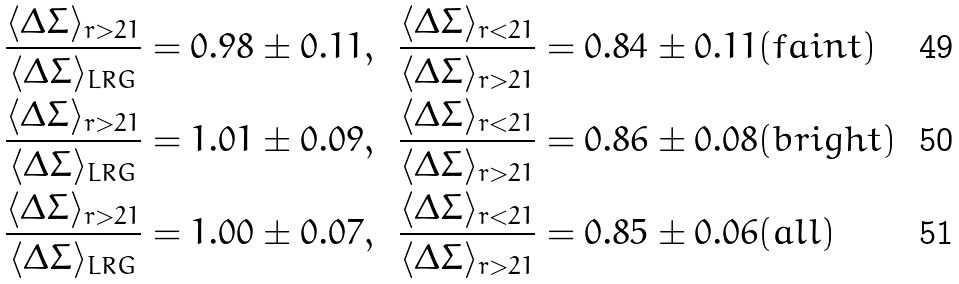Convert formula to latex. <formula><loc_0><loc_0><loc_500><loc_500>\frac { \langle \Delta \Sigma \rangle _ { r > 2 1 } } { \langle \Delta \Sigma \rangle _ { L R G } } & = 0 . 9 8 \pm 0 . 1 1 , & \frac { \langle \Delta \Sigma \rangle _ { r < 2 1 } } { \langle \Delta \Sigma \rangle _ { r > 2 1 } } & = 0 . 8 4 \pm 0 . 1 1 ( f a i n t ) \\ \frac { \langle \Delta \Sigma \rangle _ { r > 2 1 } } { \langle \Delta \Sigma \rangle _ { L R G } } & = 1 . 0 1 \pm 0 . 0 9 , & \frac { \langle \Delta \Sigma \rangle _ { r < 2 1 } } { \langle \Delta \Sigma \rangle _ { r > 2 1 } } & = 0 . 8 6 \pm 0 . 0 8 ( b r i g h t ) \\ \frac { \langle \Delta \Sigma \rangle _ { r > 2 1 } } { \langle \Delta \Sigma \rangle _ { L R G } } & = 1 . 0 0 \pm 0 . 0 7 , & \frac { \langle \Delta \Sigma \rangle _ { r < 2 1 } } { \langle \Delta \Sigma \rangle _ { r > 2 1 } } & = 0 . 8 5 \pm 0 . 0 6 ( a l l )</formula> 